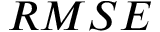<formula> <loc_0><loc_0><loc_500><loc_500>R M S E</formula> 